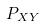Convert formula to latex. <formula><loc_0><loc_0><loc_500><loc_500>P _ { X Y }</formula> 